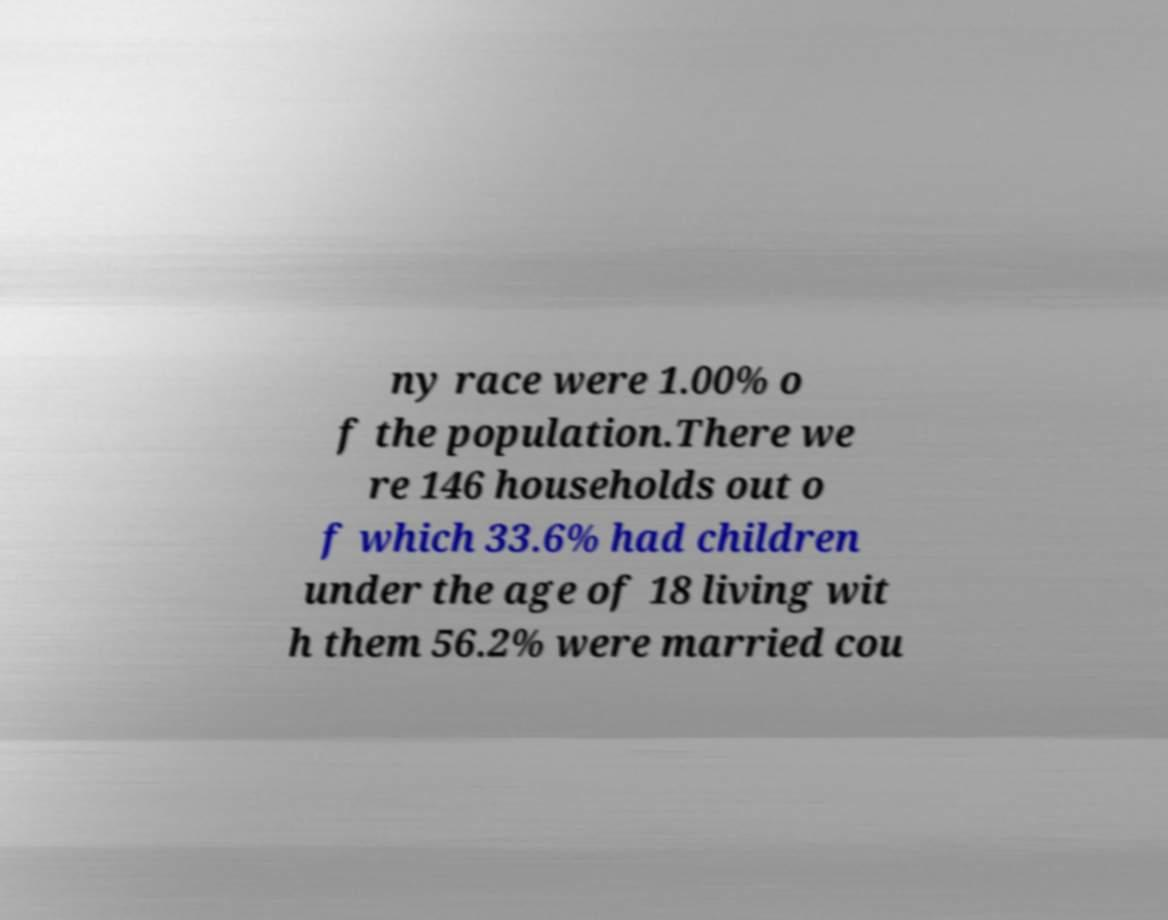I need the written content from this picture converted into text. Can you do that? ny race were 1.00% o f the population.There we re 146 households out o f which 33.6% had children under the age of 18 living wit h them 56.2% were married cou 